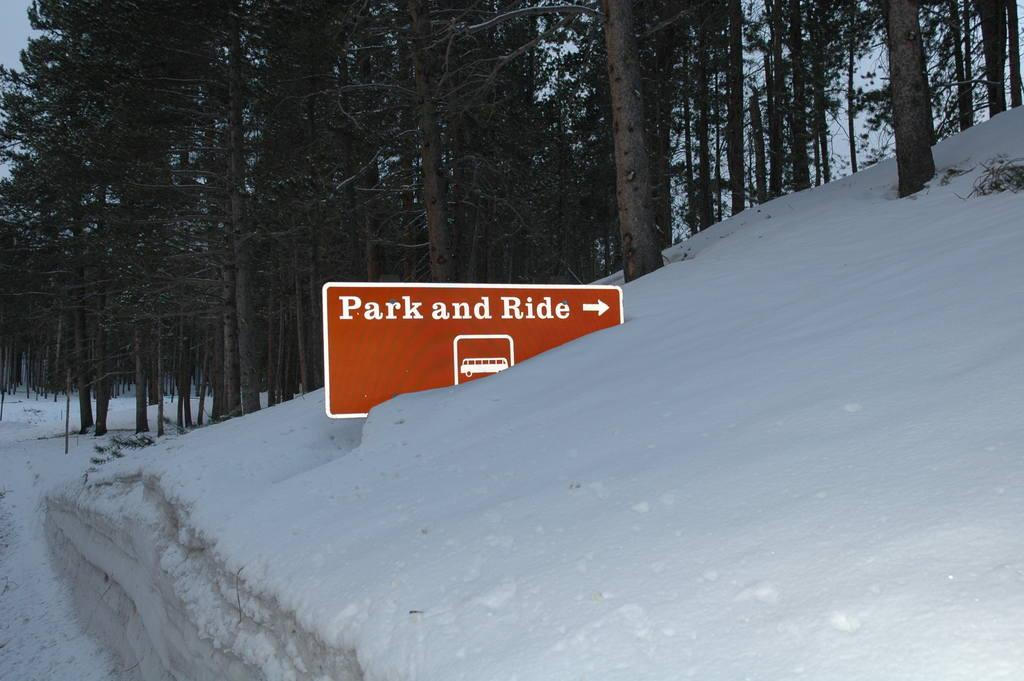What is the main object in the image? There is a direction sign board in the image. Where is the sign board located? The sign board is in the snow. What can be seen in the background of the image? There are trees visible in the background of the image. How many trains can be seen passing by in the image? There are no trains visible in the image. What type of shade is provided by the trees in the image? There is no shade mentioned in the image, as it only describes the presence of trees in the background. 